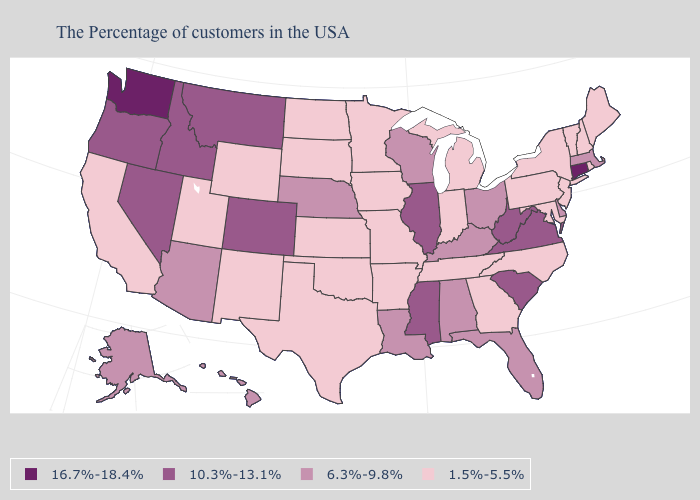Name the states that have a value in the range 16.7%-18.4%?
Answer briefly. Connecticut, Washington. Does the first symbol in the legend represent the smallest category?
Keep it brief. No. Which states have the lowest value in the Northeast?
Write a very short answer. Maine, Rhode Island, New Hampshire, Vermont, New York, New Jersey, Pennsylvania. Is the legend a continuous bar?
Answer briefly. No. Name the states that have a value in the range 1.5%-5.5%?
Concise answer only. Maine, Rhode Island, New Hampshire, Vermont, New York, New Jersey, Maryland, Pennsylvania, North Carolina, Georgia, Michigan, Indiana, Tennessee, Missouri, Arkansas, Minnesota, Iowa, Kansas, Oklahoma, Texas, South Dakota, North Dakota, Wyoming, New Mexico, Utah, California. Does New Mexico have the lowest value in the West?
Keep it brief. Yes. Name the states that have a value in the range 10.3%-13.1%?
Write a very short answer. Virginia, South Carolina, West Virginia, Illinois, Mississippi, Colorado, Montana, Idaho, Nevada, Oregon. What is the value of Arizona?
Short answer required. 6.3%-9.8%. What is the highest value in the USA?
Quick response, please. 16.7%-18.4%. Does the map have missing data?
Quick response, please. No. Name the states that have a value in the range 10.3%-13.1%?
Keep it brief. Virginia, South Carolina, West Virginia, Illinois, Mississippi, Colorado, Montana, Idaho, Nevada, Oregon. What is the value of Wisconsin?
Answer briefly. 6.3%-9.8%. What is the value of Alaska?
Answer briefly. 6.3%-9.8%. Which states have the lowest value in the USA?
Answer briefly. Maine, Rhode Island, New Hampshire, Vermont, New York, New Jersey, Maryland, Pennsylvania, North Carolina, Georgia, Michigan, Indiana, Tennessee, Missouri, Arkansas, Minnesota, Iowa, Kansas, Oklahoma, Texas, South Dakota, North Dakota, Wyoming, New Mexico, Utah, California. What is the value of Oregon?
Keep it brief. 10.3%-13.1%. 